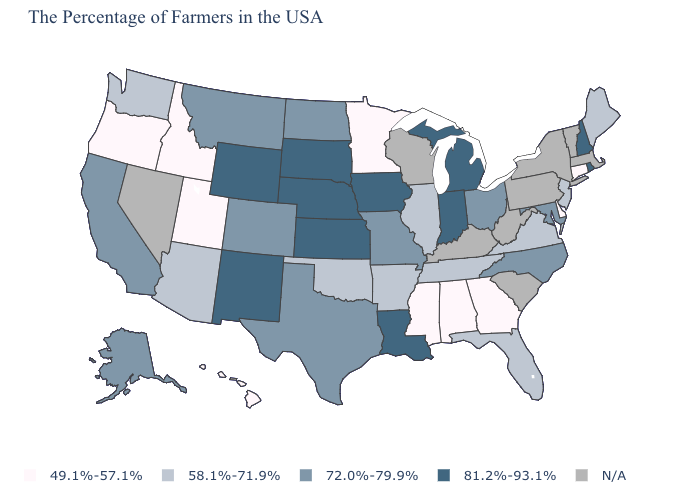What is the value of Washington?
Be succinct. 58.1%-71.9%. What is the value of South Dakota?
Short answer required. 81.2%-93.1%. What is the lowest value in the USA?
Write a very short answer. 49.1%-57.1%. What is the value of New Jersey?
Be succinct. 58.1%-71.9%. Is the legend a continuous bar?
Short answer required. No. Name the states that have a value in the range 49.1%-57.1%?
Write a very short answer. Connecticut, Delaware, Georgia, Alabama, Mississippi, Minnesota, Utah, Idaho, Oregon, Hawaii. What is the highest value in states that border South Carolina?
Answer briefly. 72.0%-79.9%. Which states hav the highest value in the Northeast?
Write a very short answer. Rhode Island, New Hampshire. Name the states that have a value in the range 81.2%-93.1%?
Be succinct. Rhode Island, New Hampshire, Michigan, Indiana, Louisiana, Iowa, Kansas, Nebraska, South Dakota, Wyoming, New Mexico. Among the states that border Nevada , which have the highest value?
Be succinct. California. Name the states that have a value in the range 49.1%-57.1%?
Give a very brief answer. Connecticut, Delaware, Georgia, Alabama, Mississippi, Minnesota, Utah, Idaho, Oregon, Hawaii. Name the states that have a value in the range N/A?
Give a very brief answer. Massachusetts, Vermont, New York, Pennsylvania, South Carolina, West Virginia, Kentucky, Wisconsin, Nevada. Name the states that have a value in the range 72.0%-79.9%?
Keep it brief. Maryland, North Carolina, Ohio, Missouri, Texas, North Dakota, Colorado, Montana, California, Alaska. Name the states that have a value in the range 58.1%-71.9%?
Give a very brief answer. Maine, New Jersey, Virginia, Florida, Tennessee, Illinois, Arkansas, Oklahoma, Arizona, Washington. 